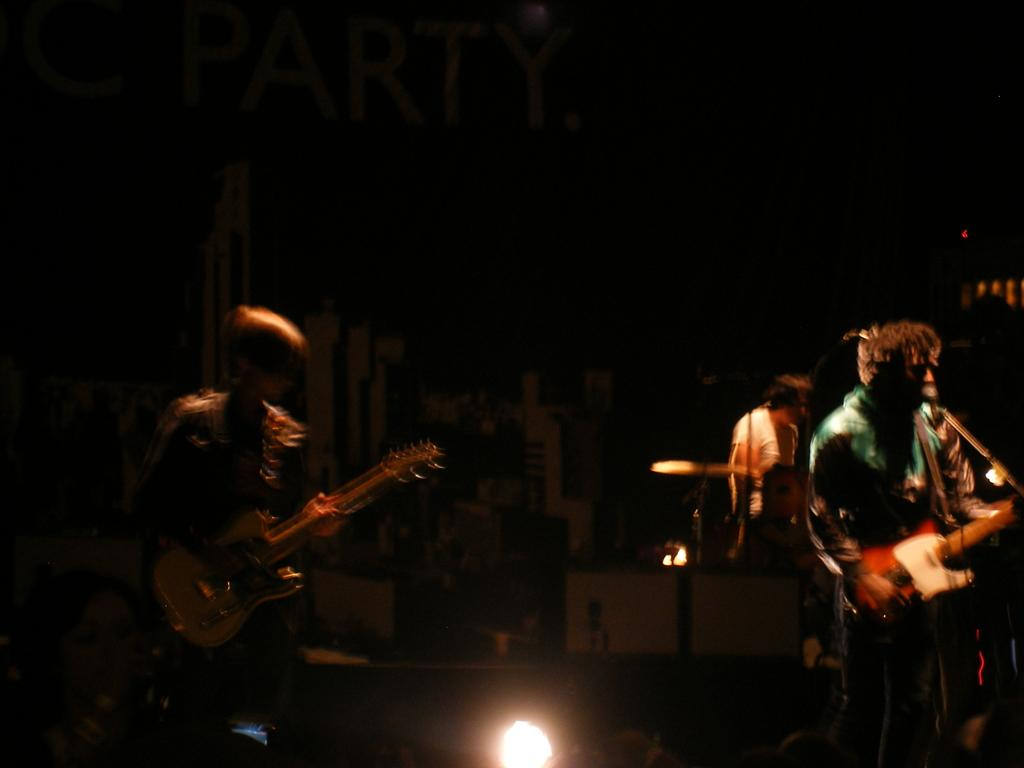Who or what can be seen in the image? There are people in the image. What are the people in the image doing? The people are standing. What objects are the people holding in their hands? The people are holding guitars in their hands. What type of quiver can be seen on the people's backs in the image? There is no quiver present on the people's backs in the image; they are holding guitars in their hands. 